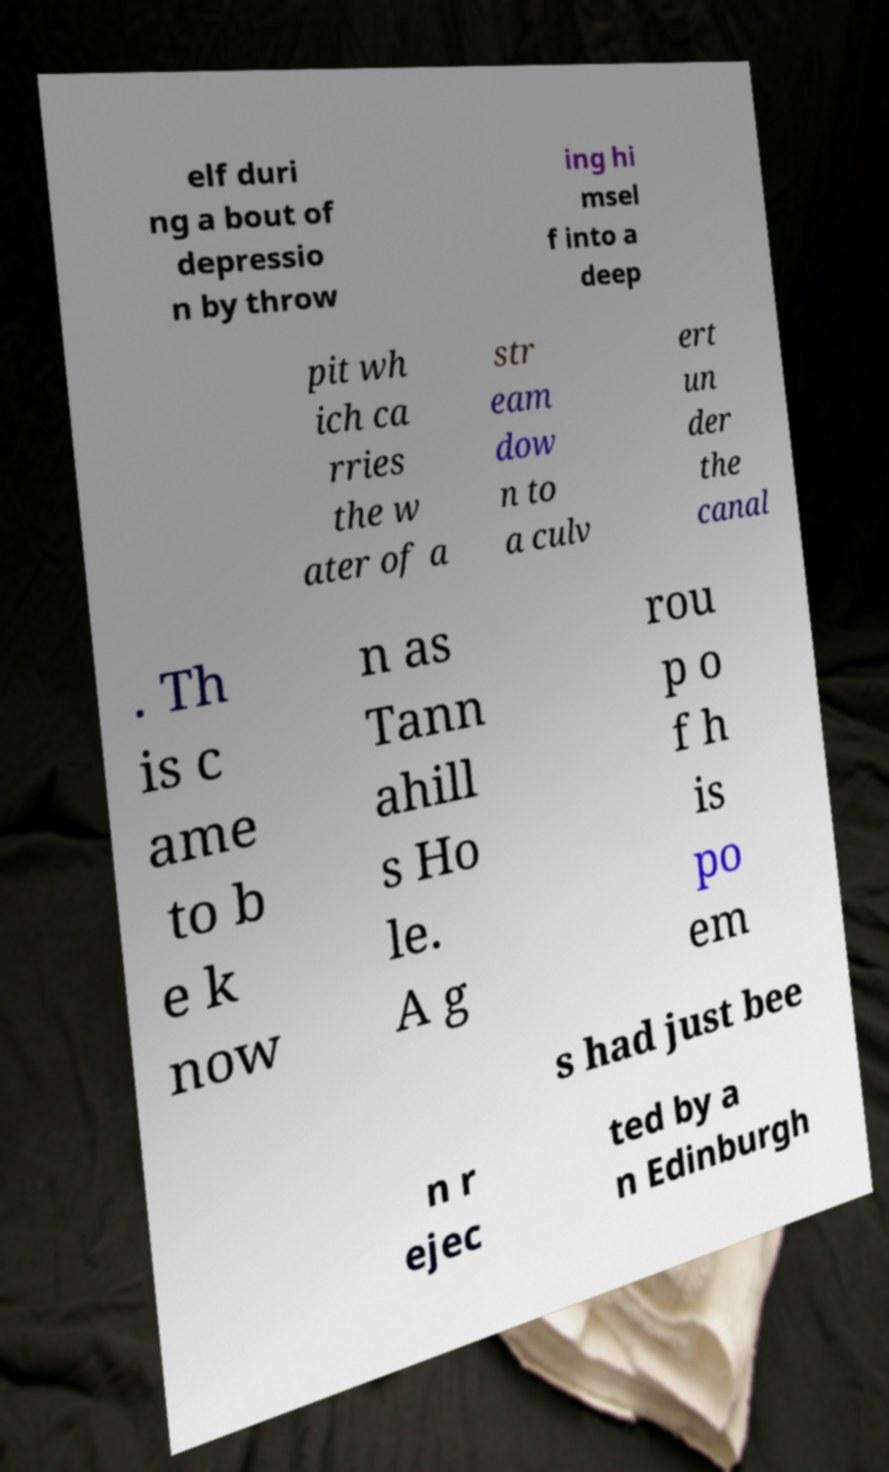Could you extract and type out the text from this image? elf duri ng a bout of depressio n by throw ing hi msel f into a deep pit wh ich ca rries the w ater of a str eam dow n to a culv ert un der the canal . Th is c ame to b e k now n as Tann ahill s Ho le. A g rou p o f h is po em s had just bee n r ejec ted by a n Edinburgh 